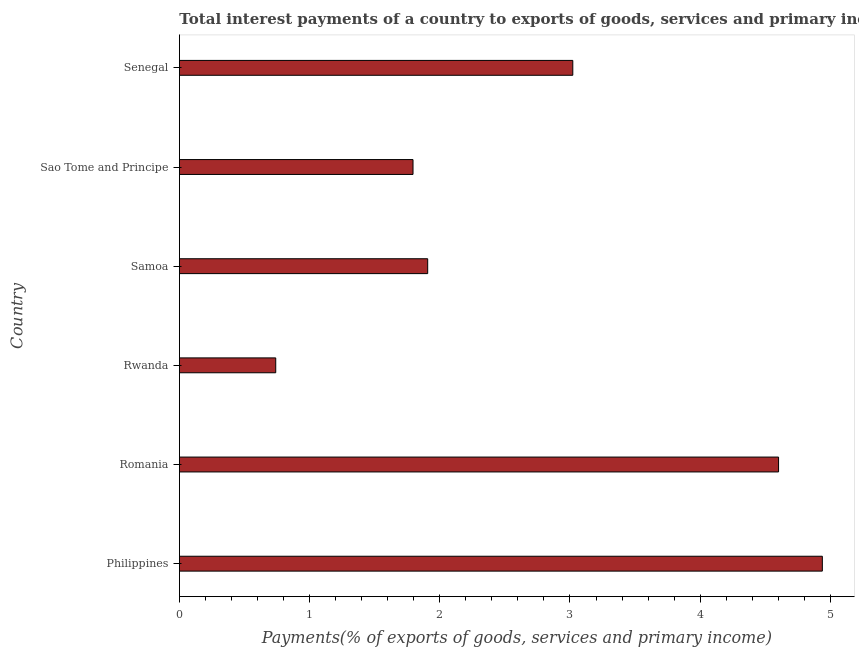Does the graph contain any zero values?
Ensure brevity in your answer.  No. What is the title of the graph?
Offer a terse response. Total interest payments of a country to exports of goods, services and primary income in 2011. What is the label or title of the X-axis?
Your answer should be compact. Payments(% of exports of goods, services and primary income). What is the label or title of the Y-axis?
Your answer should be compact. Country. What is the total interest payments on external debt in Philippines?
Ensure brevity in your answer.  4.94. Across all countries, what is the maximum total interest payments on external debt?
Give a very brief answer. 4.94. Across all countries, what is the minimum total interest payments on external debt?
Your response must be concise. 0.74. In which country was the total interest payments on external debt maximum?
Provide a short and direct response. Philippines. In which country was the total interest payments on external debt minimum?
Provide a short and direct response. Rwanda. What is the sum of the total interest payments on external debt?
Your response must be concise. 17. What is the difference between the total interest payments on external debt in Philippines and Sao Tome and Principe?
Provide a succinct answer. 3.14. What is the average total interest payments on external debt per country?
Ensure brevity in your answer.  2.83. What is the median total interest payments on external debt?
Give a very brief answer. 2.46. What is the ratio of the total interest payments on external debt in Samoa to that in Sao Tome and Principe?
Offer a terse response. 1.06. Is the difference between the total interest payments on external debt in Romania and Samoa greater than the difference between any two countries?
Keep it short and to the point. No. What is the difference between the highest and the second highest total interest payments on external debt?
Offer a terse response. 0.34. Is the sum of the total interest payments on external debt in Samoa and Sao Tome and Principe greater than the maximum total interest payments on external debt across all countries?
Provide a succinct answer. No. How many bars are there?
Provide a succinct answer. 6. Are all the bars in the graph horizontal?
Make the answer very short. Yes. What is the Payments(% of exports of goods, services and primary income) in Philippines?
Give a very brief answer. 4.94. What is the Payments(% of exports of goods, services and primary income) in Romania?
Ensure brevity in your answer.  4.6. What is the Payments(% of exports of goods, services and primary income) of Rwanda?
Provide a succinct answer. 0.74. What is the Payments(% of exports of goods, services and primary income) of Samoa?
Make the answer very short. 1.91. What is the Payments(% of exports of goods, services and primary income) in Sao Tome and Principe?
Offer a terse response. 1.79. What is the Payments(% of exports of goods, services and primary income) of Senegal?
Offer a terse response. 3.02. What is the difference between the Payments(% of exports of goods, services and primary income) in Philippines and Romania?
Your answer should be compact. 0.34. What is the difference between the Payments(% of exports of goods, services and primary income) in Philippines and Rwanda?
Provide a succinct answer. 4.2. What is the difference between the Payments(% of exports of goods, services and primary income) in Philippines and Samoa?
Your answer should be very brief. 3.03. What is the difference between the Payments(% of exports of goods, services and primary income) in Philippines and Sao Tome and Principe?
Provide a short and direct response. 3.14. What is the difference between the Payments(% of exports of goods, services and primary income) in Philippines and Senegal?
Give a very brief answer. 1.92. What is the difference between the Payments(% of exports of goods, services and primary income) in Romania and Rwanda?
Your response must be concise. 3.86. What is the difference between the Payments(% of exports of goods, services and primary income) in Romania and Samoa?
Your answer should be compact. 2.7. What is the difference between the Payments(% of exports of goods, services and primary income) in Romania and Sao Tome and Principe?
Provide a succinct answer. 2.81. What is the difference between the Payments(% of exports of goods, services and primary income) in Romania and Senegal?
Your response must be concise. 1.58. What is the difference between the Payments(% of exports of goods, services and primary income) in Rwanda and Samoa?
Provide a short and direct response. -1.17. What is the difference between the Payments(% of exports of goods, services and primary income) in Rwanda and Sao Tome and Principe?
Keep it short and to the point. -1.05. What is the difference between the Payments(% of exports of goods, services and primary income) in Rwanda and Senegal?
Offer a terse response. -2.28. What is the difference between the Payments(% of exports of goods, services and primary income) in Samoa and Sao Tome and Principe?
Offer a very short reply. 0.11. What is the difference between the Payments(% of exports of goods, services and primary income) in Samoa and Senegal?
Offer a very short reply. -1.11. What is the difference between the Payments(% of exports of goods, services and primary income) in Sao Tome and Principe and Senegal?
Give a very brief answer. -1.23. What is the ratio of the Payments(% of exports of goods, services and primary income) in Philippines to that in Romania?
Your response must be concise. 1.07. What is the ratio of the Payments(% of exports of goods, services and primary income) in Philippines to that in Rwanda?
Your response must be concise. 6.67. What is the ratio of the Payments(% of exports of goods, services and primary income) in Philippines to that in Samoa?
Offer a terse response. 2.59. What is the ratio of the Payments(% of exports of goods, services and primary income) in Philippines to that in Sao Tome and Principe?
Your response must be concise. 2.75. What is the ratio of the Payments(% of exports of goods, services and primary income) in Philippines to that in Senegal?
Give a very brief answer. 1.63. What is the ratio of the Payments(% of exports of goods, services and primary income) in Romania to that in Rwanda?
Give a very brief answer. 6.22. What is the ratio of the Payments(% of exports of goods, services and primary income) in Romania to that in Samoa?
Your answer should be compact. 2.41. What is the ratio of the Payments(% of exports of goods, services and primary income) in Romania to that in Sao Tome and Principe?
Provide a short and direct response. 2.56. What is the ratio of the Payments(% of exports of goods, services and primary income) in Romania to that in Senegal?
Your answer should be very brief. 1.52. What is the ratio of the Payments(% of exports of goods, services and primary income) in Rwanda to that in Samoa?
Your response must be concise. 0.39. What is the ratio of the Payments(% of exports of goods, services and primary income) in Rwanda to that in Sao Tome and Principe?
Ensure brevity in your answer.  0.41. What is the ratio of the Payments(% of exports of goods, services and primary income) in Rwanda to that in Senegal?
Your response must be concise. 0.24. What is the ratio of the Payments(% of exports of goods, services and primary income) in Samoa to that in Sao Tome and Principe?
Your response must be concise. 1.06. What is the ratio of the Payments(% of exports of goods, services and primary income) in Samoa to that in Senegal?
Make the answer very short. 0.63. What is the ratio of the Payments(% of exports of goods, services and primary income) in Sao Tome and Principe to that in Senegal?
Ensure brevity in your answer.  0.59. 